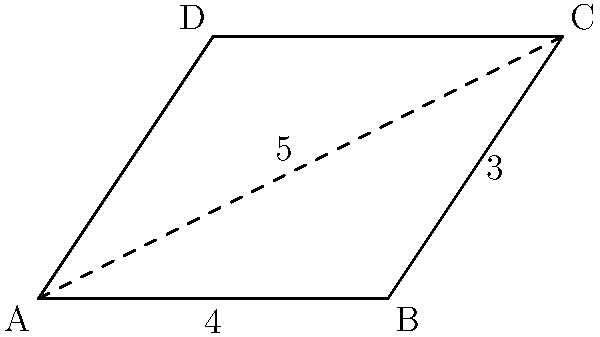In the classic sci-fi series "Space Station Alpha", a parallelogram-shaped force field is used to protect a vital section of the station. Given that the base of the force field is 4 units long, one side is 3 units long, and the diagonal measures 5 units, calculate the area of the force field. Round your answer to the nearest whole number. Let's approach this step-by-step:

1) We're dealing with a parallelogram ABCD, where:
   AB = 4 units (base)
   BC = 3 units (side)
   AC = 5 units (diagonal)

2) The area of a parallelogram is given by the formula:
   $$ \text{Area} = \text{base} \times \text{height} $$

3) We need to find the height. We can do this using the diagonal AC:
   Triangle ABC is a right-angled triangle, with AC as its hypotenuse.

4) We can use the Pythagorean theorem:
   $$ AC^2 = AB^2 + h^2 $$
   Where h is the height we're looking for.

5) Substituting the known values:
   $$ 5^2 = 4^2 + h^2 $$
   $$ 25 = 16 + h^2 $$
   $$ h^2 = 9 $$
   $$ h = 3 $$

6) Now that we have the height, we can calculate the area:
   $$ \text{Area} = \text{base} \times \text{height} $$
   $$ \text{Area} = 4 \times 3 = 12 \text{ square units} $$

7) The question asks to round to the nearest whole number, but 12 is already a whole number.

Therefore, the area of the force field is 12 square units.
Answer: 12 square units 